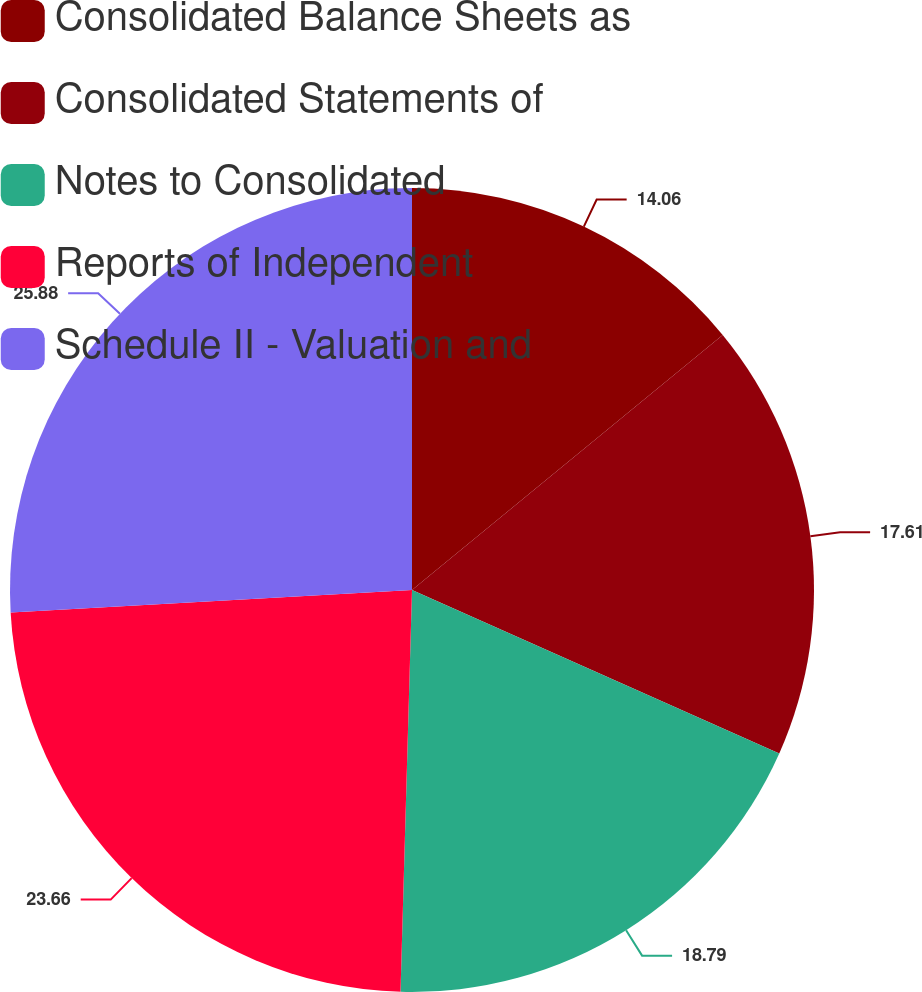Convert chart. <chart><loc_0><loc_0><loc_500><loc_500><pie_chart><fcel>Consolidated Balance Sheets as<fcel>Consolidated Statements of<fcel>Notes to Consolidated<fcel>Reports of Independent<fcel>Schedule II - Valuation and<nl><fcel>14.06%<fcel>17.61%<fcel>18.79%<fcel>23.66%<fcel>25.89%<nl></chart> 